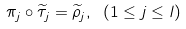Convert formula to latex. <formula><loc_0><loc_0><loc_500><loc_500>\pi _ { j } \circ \widetilde { \tau } _ { j } = \widetilde { \rho } _ { j } , \ ( 1 \leq j \leq l )</formula> 